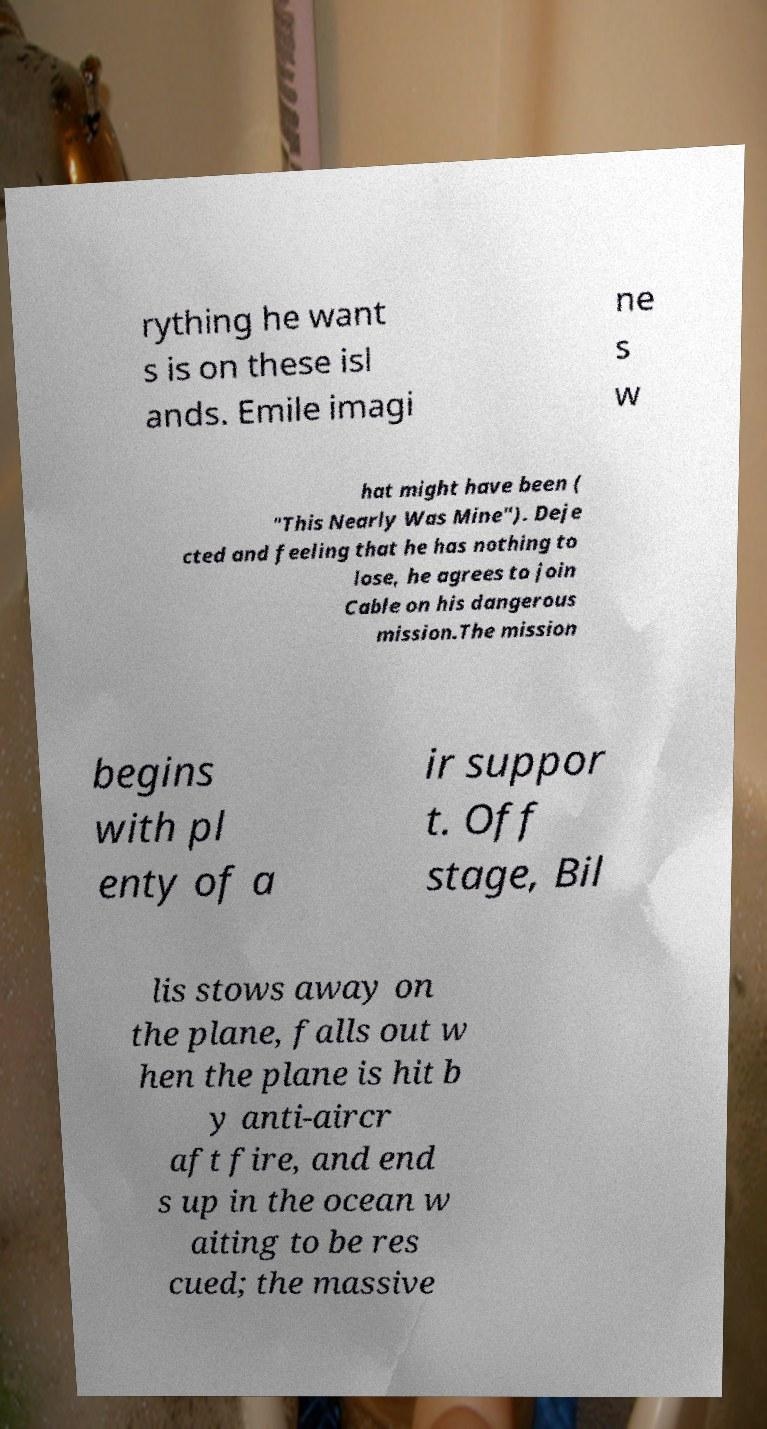Please identify and transcribe the text found in this image. rything he want s is on these isl ands. Emile imagi ne s w hat might have been ( "This Nearly Was Mine"). Deje cted and feeling that he has nothing to lose, he agrees to join Cable on his dangerous mission.The mission begins with pl enty of a ir suppor t. Off stage, Bil lis stows away on the plane, falls out w hen the plane is hit b y anti-aircr aft fire, and end s up in the ocean w aiting to be res cued; the massive 